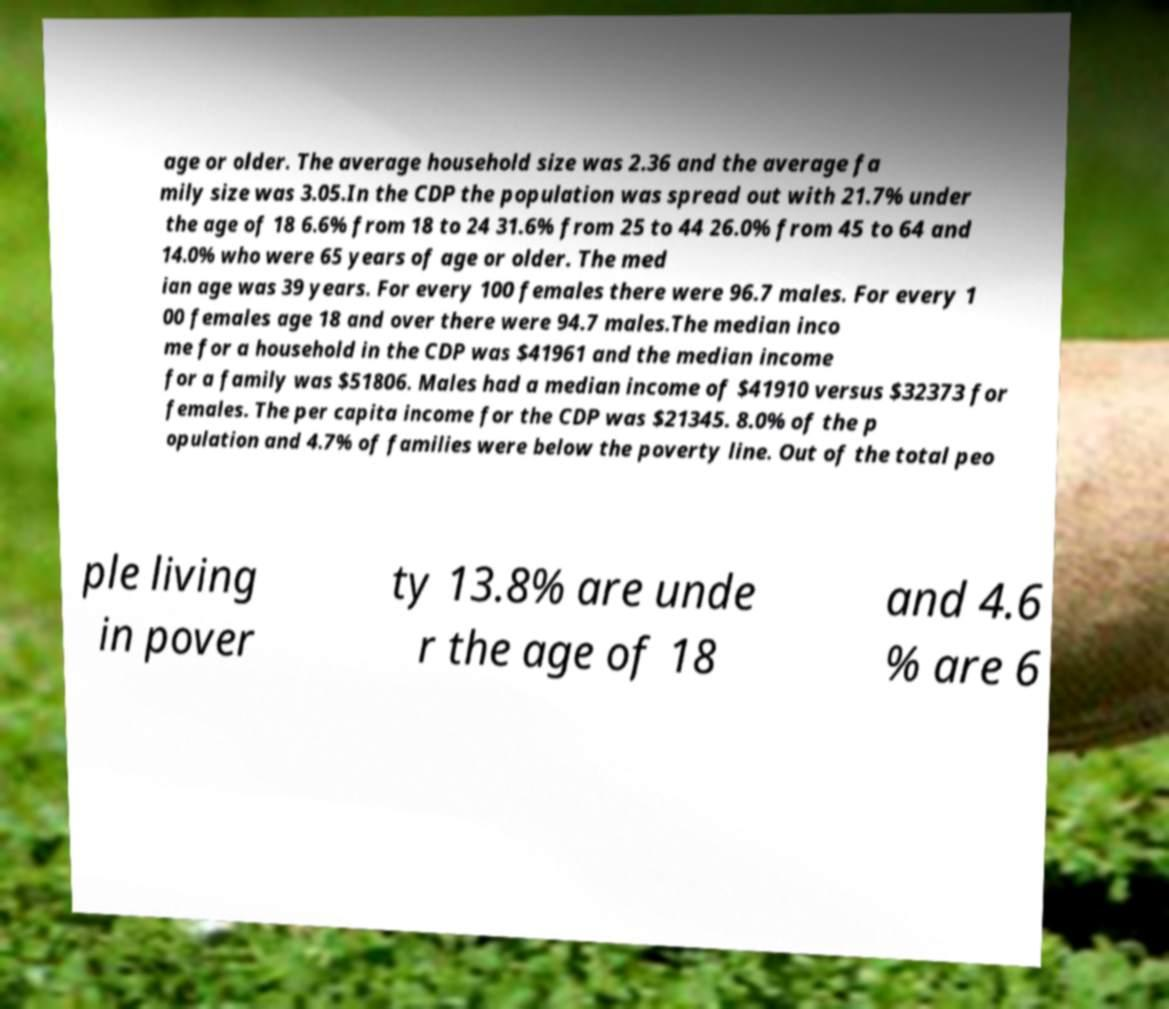There's text embedded in this image that I need extracted. Can you transcribe it verbatim? age or older. The average household size was 2.36 and the average fa mily size was 3.05.In the CDP the population was spread out with 21.7% under the age of 18 6.6% from 18 to 24 31.6% from 25 to 44 26.0% from 45 to 64 and 14.0% who were 65 years of age or older. The med ian age was 39 years. For every 100 females there were 96.7 males. For every 1 00 females age 18 and over there were 94.7 males.The median inco me for a household in the CDP was $41961 and the median income for a family was $51806. Males had a median income of $41910 versus $32373 for females. The per capita income for the CDP was $21345. 8.0% of the p opulation and 4.7% of families were below the poverty line. Out of the total peo ple living in pover ty 13.8% are unde r the age of 18 and 4.6 % are 6 